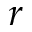<formula> <loc_0><loc_0><loc_500><loc_500>r</formula> 